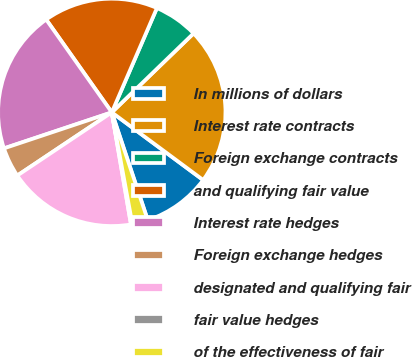Convert chart. <chart><loc_0><loc_0><loc_500><loc_500><pie_chart><fcel>In millions of dollars<fcel>Interest rate contracts<fcel>Foreign exchange contracts<fcel>and qualifying fair value<fcel>Interest rate hedges<fcel>Foreign exchange hedges<fcel>designated and qualifying fair<fcel>fair value hedges<fcel>of the effectiveness of fair<nl><fcel>9.73%<fcel>22.37%<fcel>6.28%<fcel>16.29%<fcel>20.34%<fcel>4.25%<fcel>18.32%<fcel>0.2%<fcel>2.23%<nl></chart> 